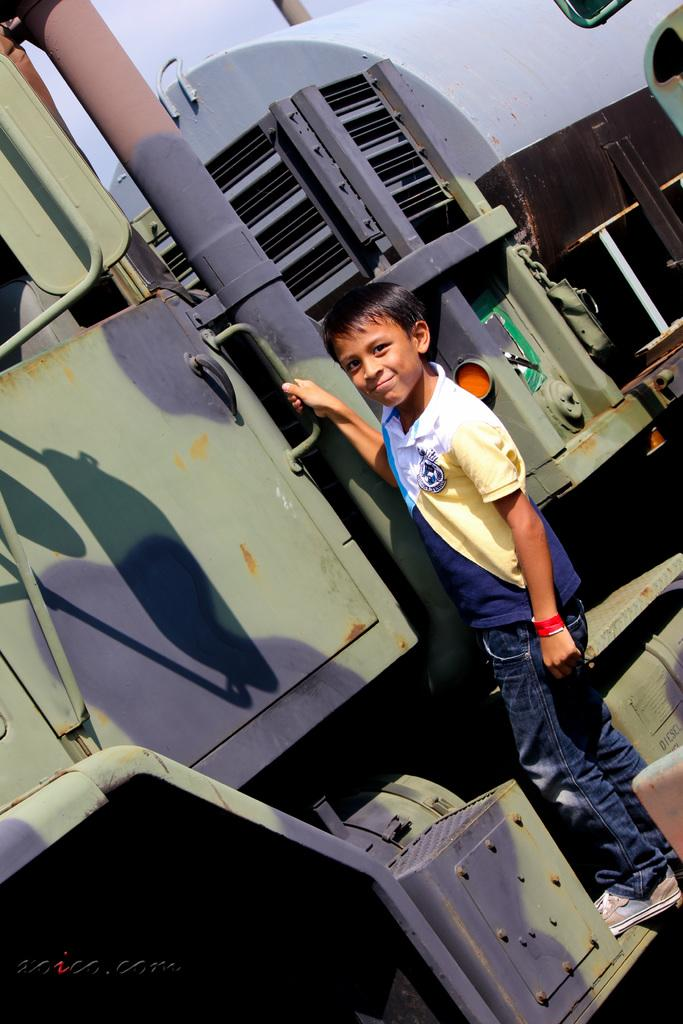What is the main subject of the image? The main subject of the image is a child. What is the child wearing in the image? The child is wearing a t-shirt, jeans, and shoes in the image. What is the child doing in the image? The child is standing on a train and smiling in the image. What type of roll can be seen being offered to the child in the image? There is no roll or any food being offered to the child in the image. What historical event is depicted in the image? The image does not depict any historical event; it features a child standing on a train and smiling. 